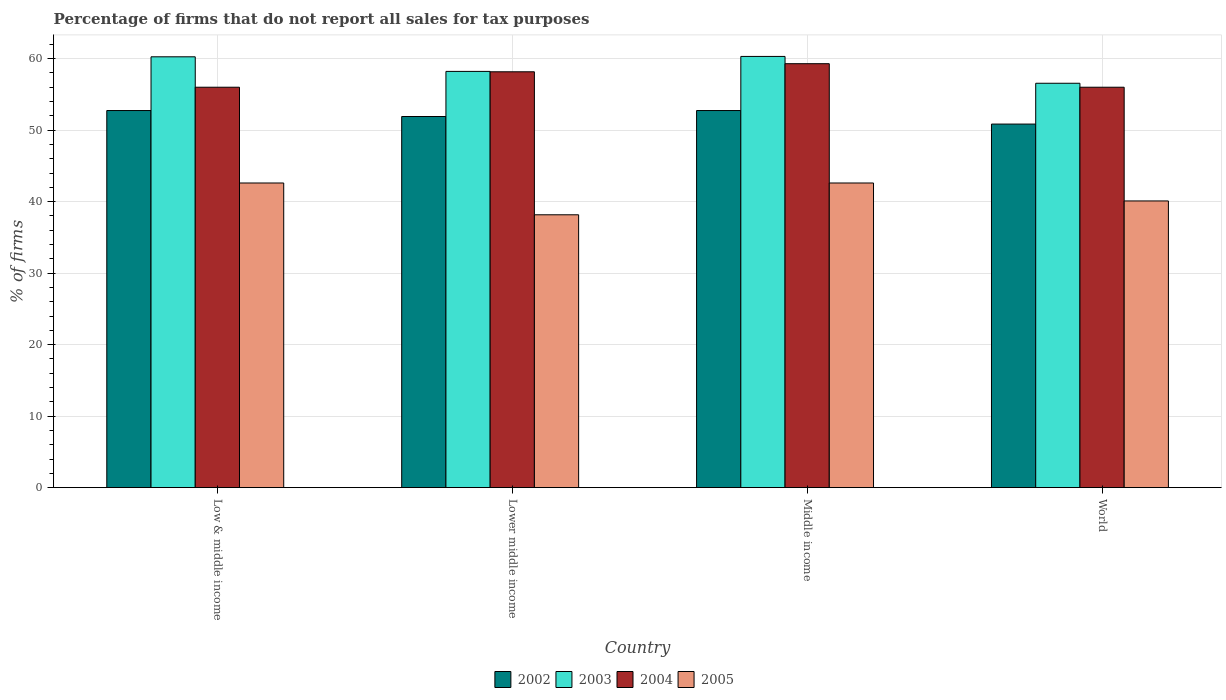How many different coloured bars are there?
Ensure brevity in your answer.  4. How many bars are there on the 1st tick from the left?
Your answer should be compact. 4. What is the label of the 1st group of bars from the left?
Ensure brevity in your answer.  Low & middle income. What is the percentage of firms that do not report all sales for tax purposes in 2002 in World?
Your answer should be very brief. 50.85. Across all countries, what is the maximum percentage of firms that do not report all sales for tax purposes in 2002?
Keep it short and to the point. 52.75. Across all countries, what is the minimum percentage of firms that do not report all sales for tax purposes in 2005?
Provide a succinct answer. 38.16. In which country was the percentage of firms that do not report all sales for tax purposes in 2002 maximum?
Provide a succinct answer. Low & middle income. In which country was the percentage of firms that do not report all sales for tax purposes in 2003 minimum?
Provide a short and direct response. World. What is the total percentage of firms that do not report all sales for tax purposes in 2005 in the graph?
Provide a succinct answer. 163.48. What is the difference between the percentage of firms that do not report all sales for tax purposes in 2003 in Lower middle income and that in Middle income?
Your response must be concise. -2.09. What is the difference between the percentage of firms that do not report all sales for tax purposes in 2005 in Middle income and the percentage of firms that do not report all sales for tax purposes in 2003 in World?
Your response must be concise. -13.95. What is the average percentage of firms that do not report all sales for tax purposes in 2002 per country?
Provide a succinct answer. 52.06. What is the difference between the percentage of firms that do not report all sales for tax purposes of/in 2002 and percentage of firms that do not report all sales for tax purposes of/in 2003 in Low & middle income?
Offer a very short reply. -7.51. In how many countries, is the percentage of firms that do not report all sales for tax purposes in 2002 greater than 24 %?
Your answer should be very brief. 4. What is the ratio of the percentage of firms that do not report all sales for tax purposes in 2002 in Lower middle income to that in World?
Make the answer very short. 1.02. Is the percentage of firms that do not report all sales for tax purposes in 2005 in Middle income less than that in World?
Provide a succinct answer. No. What is the difference between the highest and the second highest percentage of firms that do not report all sales for tax purposes in 2004?
Give a very brief answer. -2.16. What is the difference between the highest and the lowest percentage of firms that do not report all sales for tax purposes in 2003?
Make the answer very short. 3.75. In how many countries, is the percentage of firms that do not report all sales for tax purposes in 2003 greater than the average percentage of firms that do not report all sales for tax purposes in 2003 taken over all countries?
Provide a short and direct response. 2. Is it the case that in every country, the sum of the percentage of firms that do not report all sales for tax purposes in 2002 and percentage of firms that do not report all sales for tax purposes in 2004 is greater than the percentage of firms that do not report all sales for tax purposes in 2005?
Give a very brief answer. Yes. How many countries are there in the graph?
Ensure brevity in your answer.  4. Are the values on the major ticks of Y-axis written in scientific E-notation?
Your response must be concise. No. How many legend labels are there?
Give a very brief answer. 4. How are the legend labels stacked?
Give a very brief answer. Horizontal. What is the title of the graph?
Provide a succinct answer. Percentage of firms that do not report all sales for tax purposes. What is the label or title of the Y-axis?
Provide a succinct answer. % of firms. What is the % of firms in 2002 in Low & middle income?
Offer a terse response. 52.75. What is the % of firms of 2003 in Low & middle income?
Give a very brief answer. 60.26. What is the % of firms of 2004 in Low & middle income?
Ensure brevity in your answer.  56.01. What is the % of firms of 2005 in Low & middle income?
Keep it short and to the point. 42.61. What is the % of firms of 2002 in Lower middle income?
Your answer should be very brief. 51.91. What is the % of firms of 2003 in Lower middle income?
Ensure brevity in your answer.  58.22. What is the % of firms of 2004 in Lower middle income?
Give a very brief answer. 58.16. What is the % of firms of 2005 in Lower middle income?
Keep it short and to the point. 38.16. What is the % of firms of 2002 in Middle income?
Your answer should be very brief. 52.75. What is the % of firms of 2003 in Middle income?
Offer a very short reply. 60.31. What is the % of firms in 2004 in Middle income?
Provide a succinct answer. 59.3. What is the % of firms in 2005 in Middle income?
Provide a short and direct response. 42.61. What is the % of firms of 2002 in World?
Ensure brevity in your answer.  50.85. What is the % of firms in 2003 in World?
Provide a short and direct response. 56.56. What is the % of firms in 2004 in World?
Keep it short and to the point. 56.01. What is the % of firms of 2005 in World?
Give a very brief answer. 40.1. Across all countries, what is the maximum % of firms in 2002?
Your answer should be very brief. 52.75. Across all countries, what is the maximum % of firms in 2003?
Your answer should be compact. 60.31. Across all countries, what is the maximum % of firms in 2004?
Provide a short and direct response. 59.3. Across all countries, what is the maximum % of firms in 2005?
Offer a terse response. 42.61. Across all countries, what is the minimum % of firms of 2002?
Your answer should be compact. 50.85. Across all countries, what is the minimum % of firms of 2003?
Ensure brevity in your answer.  56.56. Across all countries, what is the minimum % of firms of 2004?
Give a very brief answer. 56.01. Across all countries, what is the minimum % of firms in 2005?
Make the answer very short. 38.16. What is the total % of firms of 2002 in the graph?
Provide a succinct answer. 208.25. What is the total % of firms in 2003 in the graph?
Offer a very short reply. 235.35. What is the total % of firms in 2004 in the graph?
Provide a short and direct response. 229.47. What is the total % of firms in 2005 in the graph?
Provide a succinct answer. 163.48. What is the difference between the % of firms in 2002 in Low & middle income and that in Lower middle income?
Offer a terse response. 0.84. What is the difference between the % of firms in 2003 in Low & middle income and that in Lower middle income?
Provide a short and direct response. 2.04. What is the difference between the % of firms of 2004 in Low & middle income and that in Lower middle income?
Provide a short and direct response. -2.16. What is the difference between the % of firms of 2005 in Low & middle income and that in Lower middle income?
Provide a succinct answer. 4.45. What is the difference between the % of firms of 2003 in Low & middle income and that in Middle income?
Your answer should be very brief. -0.05. What is the difference between the % of firms in 2004 in Low & middle income and that in Middle income?
Your answer should be very brief. -3.29. What is the difference between the % of firms of 2002 in Low & middle income and that in World?
Your answer should be very brief. 1.89. What is the difference between the % of firms of 2003 in Low & middle income and that in World?
Keep it short and to the point. 3.7. What is the difference between the % of firms in 2005 in Low & middle income and that in World?
Offer a terse response. 2.51. What is the difference between the % of firms in 2002 in Lower middle income and that in Middle income?
Keep it short and to the point. -0.84. What is the difference between the % of firms in 2003 in Lower middle income and that in Middle income?
Your answer should be very brief. -2.09. What is the difference between the % of firms in 2004 in Lower middle income and that in Middle income?
Offer a very short reply. -1.13. What is the difference between the % of firms in 2005 in Lower middle income and that in Middle income?
Your response must be concise. -4.45. What is the difference between the % of firms in 2002 in Lower middle income and that in World?
Your answer should be very brief. 1.06. What is the difference between the % of firms of 2003 in Lower middle income and that in World?
Provide a succinct answer. 1.66. What is the difference between the % of firms of 2004 in Lower middle income and that in World?
Your answer should be very brief. 2.16. What is the difference between the % of firms of 2005 in Lower middle income and that in World?
Offer a terse response. -1.94. What is the difference between the % of firms in 2002 in Middle income and that in World?
Ensure brevity in your answer.  1.89. What is the difference between the % of firms of 2003 in Middle income and that in World?
Your response must be concise. 3.75. What is the difference between the % of firms in 2004 in Middle income and that in World?
Offer a terse response. 3.29. What is the difference between the % of firms of 2005 in Middle income and that in World?
Ensure brevity in your answer.  2.51. What is the difference between the % of firms in 2002 in Low & middle income and the % of firms in 2003 in Lower middle income?
Keep it short and to the point. -5.47. What is the difference between the % of firms of 2002 in Low & middle income and the % of firms of 2004 in Lower middle income?
Offer a terse response. -5.42. What is the difference between the % of firms in 2002 in Low & middle income and the % of firms in 2005 in Lower middle income?
Your response must be concise. 14.58. What is the difference between the % of firms in 2003 in Low & middle income and the % of firms in 2004 in Lower middle income?
Provide a short and direct response. 2.1. What is the difference between the % of firms of 2003 in Low & middle income and the % of firms of 2005 in Lower middle income?
Offer a terse response. 22.1. What is the difference between the % of firms of 2004 in Low & middle income and the % of firms of 2005 in Lower middle income?
Provide a short and direct response. 17.84. What is the difference between the % of firms of 2002 in Low & middle income and the % of firms of 2003 in Middle income?
Your answer should be very brief. -7.57. What is the difference between the % of firms in 2002 in Low & middle income and the % of firms in 2004 in Middle income?
Offer a very short reply. -6.55. What is the difference between the % of firms of 2002 in Low & middle income and the % of firms of 2005 in Middle income?
Provide a succinct answer. 10.13. What is the difference between the % of firms of 2003 in Low & middle income and the % of firms of 2004 in Middle income?
Keep it short and to the point. 0.96. What is the difference between the % of firms in 2003 in Low & middle income and the % of firms in 2005 in Middle income?
Your answer should be compact. 17.65. What is the difference between the % of firms in 2004 in Low & middle income and the % of firms in 2005 in Middle income?
Ensure brevity in your answer.  13.39. What is the difference between the % of firms of 2002 in Low & middle income and the % of firms of 2003 in World?
Make the answer very short. -3.81. What is the difference between the % of firms of 2002 in Low & middle income and the % of firms of 2004 in World?
Provide a succinct answer. -3.26. What is the difference between the % of firms in 2002 in Low & middle income and the % of firms in 2005 in World?
Your answer should be very brief. 12.65. What is the difference between the % of firms in 2003 in Low & middle income and the % of firms in 2004 in World?
Your answer should be compact. 4.25. What is the difference between the % of firms in 2003 in Low & middle income and the % of firms in 2005 in World?
Offer a very short reply. 20.16. What is the difference between the % of firms in 2004 in Low & middle income and the % of firms in 2005 in World?
Your response must be concise. 15.91. What is the difference between the % of firms in 2002 in Lower middle income and the % of firms in 2003 in Middle income?
Offer a terse response. -8.4. What is the difference between the % of firms of 2002 in Lower middle income and the % of firms of 2004 in Middle income?
Offer a terse response. -7.39. What is the difference between the % of firms of 2002 in Lower middle income and the % of firms of 2005 in Middle income?
Keep it short and to the point. 9.3. What is the difference between the % of firms of 2003 in Lower middle income and the % of firms of 2004 in Middle income?
Your answer should be very brief. -1.08. What is the difference between the % of firms in 2003 in Lower middle income and the % of firms in 2005 in Middle income?
Offer a terse response. 15.61. What is the difference between the % of firms in 2004 in Lower middle income and the % of firms in 2005 in Middle income?
Your answer should be very brief. 15.55. What is the difference between the % of firms of 2002 in Lower middle income and the % of firms of 2003 in World?
Make the answer very short. -4.65. What is the difference between the % of firms in 2002 in Lower middle income and the % of firms in 2004 in World?
Provide a succinct answer. -4.1. What is the difference between the % of firms in 2002 in Lower middle income and the % of firms in 2005 in World?
Give a very brief answer. 11.81. What is the difference between the % of firms in 2003 in Lower middle income and the % of firms in 2004 in World?
Provide a succinct answer. 2.21. What is the difference between the % of firms of 2003 in Lower middle income and the % of firms of 2005 in World?
Give a very brief answer. 18.12. What is the difference between the % of firms of 2004 in Lower middle income and the % of firms of 2005 in World?
Keep it short and to the point. 18.07. What is the difference between the % of firms of 2002 in Middle income and the % of firms of 2003 in World?
Your answer should be very brief. -3.81. What is the difference between the % of firms in 2002 in Middle income and the % of firms in 2004 in World?
Your answer should be very brief. -3.26. What is the difference between the % of firms in 2002 in Middle income and the % of firms in 2005 in World?
Provide a succinct answer. 12.65. What is the difference between the % of firms in 2003 in Middle income and the % of firms in 2004 in World?
Offer a very short reply. 4.31. What is the difference between the % of firms in 2003 in Middle income and the % of firms in 2005 in World?
Your response must be concise. 20.21. What is the difference between the % of firms in 2004 in Middle income and the % of firms in 2005 in World?
Your answer should be very brief. 19.2. What is the average % of firms in 2002 per country?
Provide a short and direct response. 52.06. What is the average % of firms of 2003 per country?
Give a very brief answer. 58.84. What is the average % of firms of 2004 per country?
Give a very brief answer. 57.37. What is the average % of firms in 2005 per country?
Make the answer very short. 40.87. What is the difference between the % of firms of 2002 and % of firms of 2003 in Low & middle income?
Your answer should be compact. -7.51. What is the difference between the % of firms in 2002 and % of firms in 2004 in Low & middle income?
Ensure brevity in your answer.  -3.26. What is the difference between the % of firms of 2002 and % of firms of 2005 in Low & middle income?
Your answer should be very brief. 10.13. What is the difference between the % of firms of 2003 and % of firms of 2004 in Low & middle income?
Your response must be concise. 4.25. What is the difference between the % of firms of 2003 and % of firms of 2005 in Low & middle income?
Offer a very short reply. 17.65. What is the difference between the % of firms of 2004 and % of firms of 2005 in Low & middle income?
Offer a terse response. 13.39. What is the difference between the % of firms in 2002 and % of firms in 2003 in Lower middle income?
Ensure brevity in your answer.  -6.31. What is the difference between the % of firms of 2002 and % of firms of 2004 in Lower middle income?
Offer a very short reply. -6.26. What is the difference between the % of firms of 2002 and % of firms of 2005 in Lower middle income?
Provide a succinct answer. 13.75. What is the difference between the % of firms of 2003 and % of firms of 2004 in Lower middle income?
Make the answer very short. 0.05. What is the difference between the % of firms of 2003 and % of firms of 2005 in Lower middle income?
Provide a succinct answer. 20.06. What is the difference between the % of firms in 2004 and % of firms in 2005 in Lower middle income?
Provide a succinct answer. 20. What is the difference between the % of firms of 2002 and % of firms of 2003 in Middle income?
Offer a very short reply. -7.57. What is the difference between the % of firms in 2002 and % of firms in 2004 in Middle income?
Give a very brief answer. -6.55. What is the difference between the % of firms of 2002 and % of firms of 2005 in Middle income?
Make the answer very short. 10.13. What is the difference between the % of firms of 2003 and % of firms of 2004 in Middle income?
Make the answer very short. 1.02. What is the difference between the % of firms in 2003 and % of firms in 2005 in Middle income?
Provide a succinct answer. 17.7. What is the difference between the % of firms of 2004 and % of firms of 2005 in Middle income?
Offer a terse response. 16.69. What is the difference between the % of firms of 2002 and % of firms of 2003 in World?
Your answer should be compact. -5.71. What is the difference between the % of firms in 2002 and % of firms in 2004 in World?
Provide a succinct answer. -5.15. What is the difference between the % of firms of 2002 and % of firms of 2005 in World?
Keep it short and to the point. 10.75. What is the difference between the % of firms in 2003 and % of firms in 2004 in World?
Ensure brevity in your answer.  0.56. What is the difference between the % of firms of 2003 and % of firms of 2005 in World?
Your response must be concise. 16.46. What is the difference between the % of firms in 2004 and % of firms in 2005 in World?
Offer a terse response. 15.91. What is the ratio of the % of firms of 2002 in Low & middle income to that in Lower middle income?
Provide a short and direct response. 1.02. What is the ratio of the % of firms in 2003 in Low & middle income to that in Lower middle income?
Offer a very short reply. 1.04. What is the ratio of the % of firms in 2004 in Low & middle income to that in Lower middle income?
Keep it short and to the point. 0.96. What is the ratio of the % of firms of 2005 in Low & middle income to that in Lower middle income?
Your answer should be very brief. 1.12. What is the ratio of the % of firms in 2002 in Low & middle income to that in Middle income?
Give a very brief answer. 1. What is the ratio of the % of firms in 2003 in Low & middle income to that in Middle income?
Offer a very short reply. 1. What is the ratio of the % of firms of 2004 in Low & middle income to that in Middle income?
Provide a succinct answer. 0.94. What is the ratio of the % of firms of 2005 in Low & middle income to that in Middle income?
Provide a short and direct response. 1. What is the ratio of the % of firms in 2002 in Low & middle income to that in World?
Offer a terse response. 1.04. What is the ratio of the % of firms in 2003 in Low & middle income to that in World?
Provide a short and direct response. 1.07. What is the ratio of the % of firms of 2004 in Low & middle income to that in World?
Your answer should be compact. 1. What is the ratio of the % of firms in 2005 in Low & middle income to that in World?
Ensure brevity in your answer.  1.06. What is the ratio of the % of firms of 2002 in Lower middle income to that in Middle income?
Your answer should be compact. 0.98. What is the ratio of the % of firms in 2003 in Lower middle income to that in Middle income?
Provide a succinct answer. 0.97. What is the ratio of the % of firms in 2004 in Lower middle income to that in Middle income?
Offer a terse response. 0.98. What is the ratio of the % of firms of 2005 in Lower middle income to that in Middle income?
Provide a succinct answer. 0.9. What is the ratio of the % of firms in 2002 in Lower middle income to that in World?
Ensure brevity in your answer.  1.02. What is the ratio of the % of firms of 2003 in Lower middle income to that in World?
Provide a succinct answer. 1.03. What is the ratio of the % of firms in 2004 in Lower middle income to that in World?
Provide a succinct answer. 1.04. What is the ratio of the % of firms in 2005 in Lower middle income to that in World?
Your answer should be compact. 0.95. What is the ratio of the % of firms in 2002 in Middle income to that in World?
Make the answer very short. 1.04. What is the ratio of the % of firms of 2003 in Middle income to that in World?
Give a very brief answer. 1.07. What is the ratio of the % of firms of 2004 in Middle income to that in World?
Offer a very short reply. 1.06. What is the ratio of the % of firms of 2005 in Middle income to that in World?
Provide a succinct answer. 1.06. What is the difference between the highest and the second highest % of firms in 2002?
Your answer should be compact. 0. What is the difference between the highest and the second highest % of firms of 2003?
Ensure brevity in your answer.  0.05. What is the difference between the highest and the second highest % of firms in 2004?
Ensure brevity in your answer.  1.13. What is the difference between the highest and the second highest % of firms of 2005?
Provide a short and direct response. 0. What is the difference between the highest and the lowest % of firms in 2002?
Offer a terse response. 1.89. What is the difference between the highest and the lowest % of firms of 2003?
Offer a terse response. 3.75. What is the difference between the highest and the lowest % of firms of 2004?
Keep it short and to the point. 3.29. What is the difference between the highest and the lowest % of firms in 2005?
Ensure brevity in your answer.  4.45. 